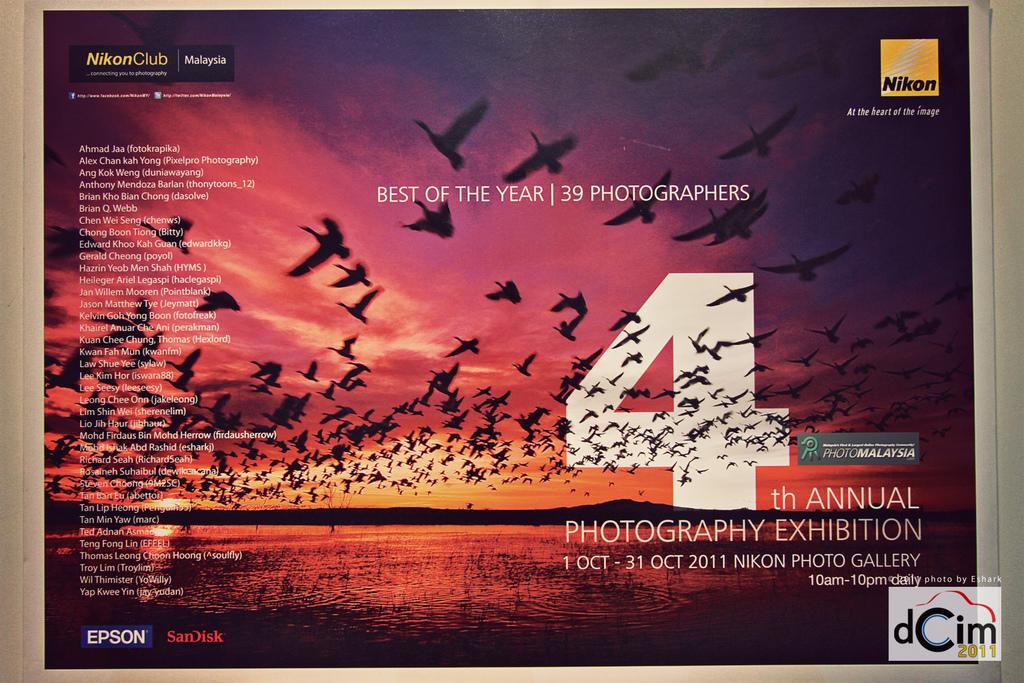When is the photo gallery open?
Offer a terse response. 10am-10pm daily. What year is this annual exhibition?
Your answer should be very brief. 2011. 